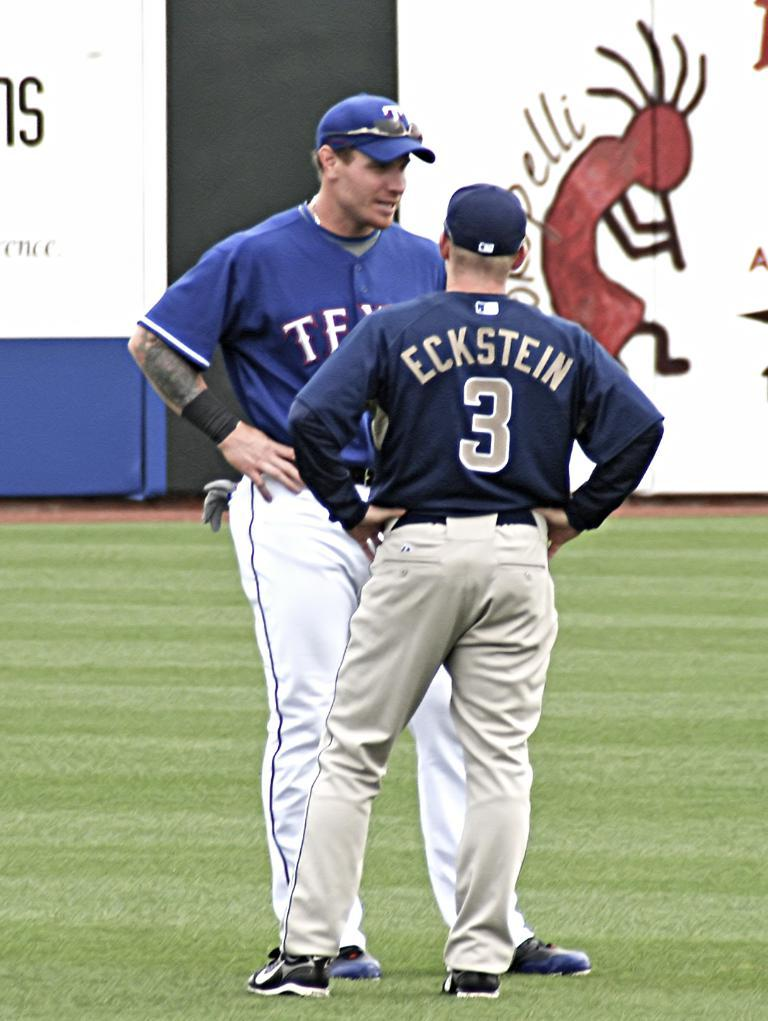Provide a one-sentence caption for the provided image. Two baseball players talking to each other, one of which is number 3. 